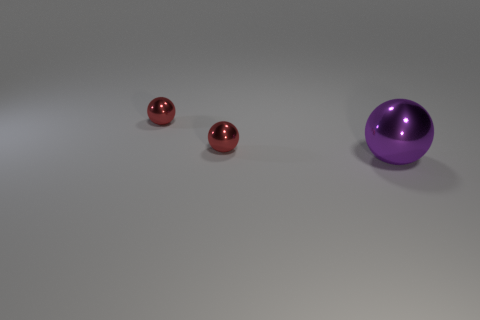Are there any other things that are the same size as the purple object?
Your response must be concise. No. How many blocks are either tiny objects or large things?
Offer a terse response. 0. Is the number of tiny red things that are behind the large purple thing less than the number of small balls?
Provide a succinct answer. No. How many things are either balls to the left of the large metallic thing or large gray cylinders?
Offer a very short reply. 2. Are there any large metallic objects that have the same color as the large sphere?
Provide a succinct answer. No. What number of other things are the same material as the purple ball?
Your answer should be very brief. 2. Is there anything else that has the same color as the large thing?
Your response must be concise. No. The big purple object is what shape?
Offer a terse response. Sphere. What number of things are either metal things on the left side of the big sphere or objects behind the large shiny sphere?
Give a very brief answer. 2. Are there more large purple things than small yellow cubes?
Your response must be concise. Yes. 